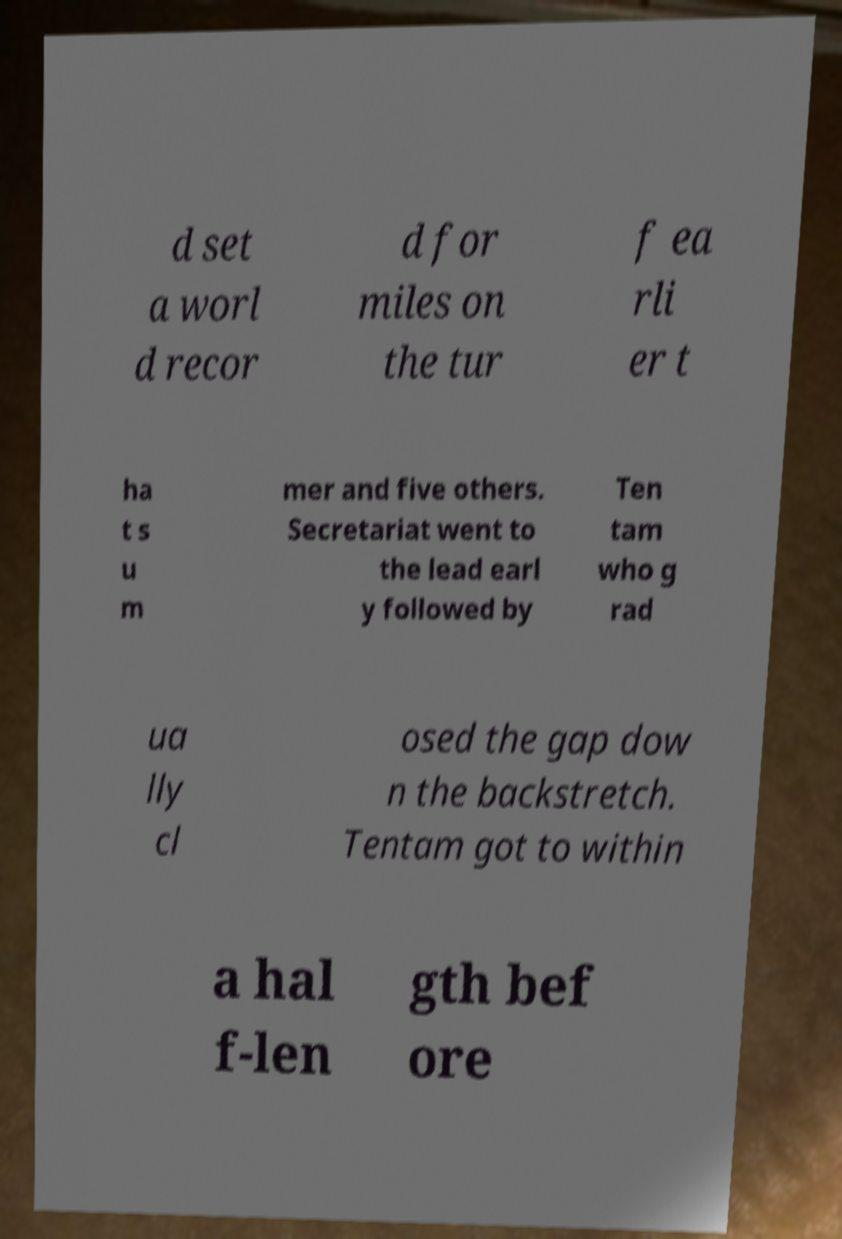Please identify and transcribe the text found in this image. d set a worl d recor d for miles on the tur f ea rli er t ha t s u m mer and five others. Secretariat went to the lead earl y followed by Ten tam who g rad ua lly cl osed the gap dow n the backstretch. Tentam got to within a hal f-len gth bef ore 